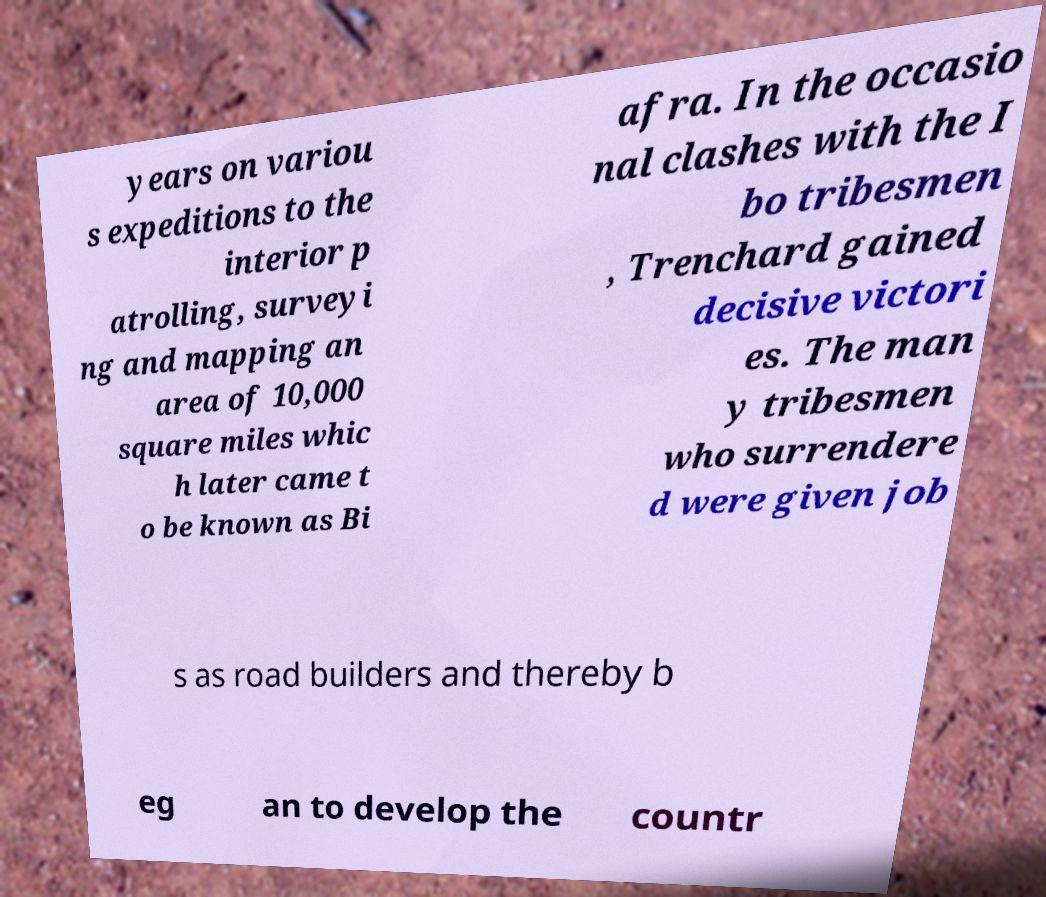There's text embedded in this image that I need extracted. Can you transcribe it verbatim? years on variou s expeditions to the interior p atrolling, surveyi ng and mapping an area of 10,000 square miles whic h later came t o be known as Bi afra. In the occasio nal clashes with the I bo tribesmen , Trenchard gained decisive victori es. The man y tribesmen who surrendere d were given job s as road builders and thereby b eg an to develop the countr 